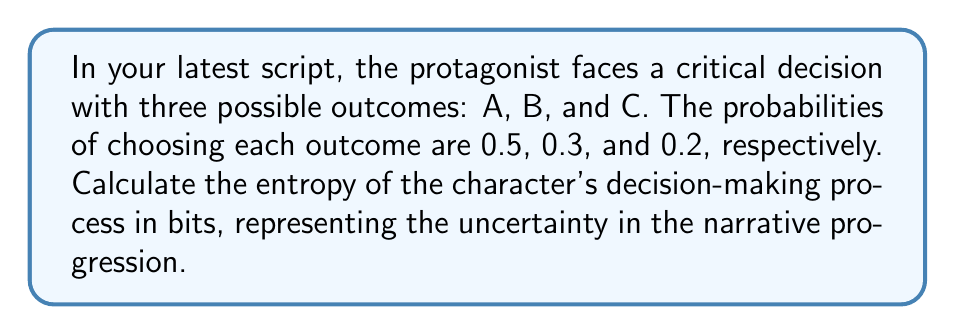Could you help me with this problem? To calculate the entropy of the character's decision-making process, we'll use the Shannon entropy formula:

$$ H = -\sum_{i=1}^{n} p_i \log_2(p_i) $$

Where:
- $H$ is the entropy in bits
- $p_i$ is the probability of each outcome
- $n$ is the number of possible outcomes

Step 1: Identify the probabilities
$p_A = 0.5$
$p_B = 0.3$
$p_C = 0.2$

Step 2: Calculate each term in the summation
For outcome A: $-0.5 \log_2(0.5) = 0.5$
For outcome B: $-0.3 \log_2(0.3) \approx 0.5211$
For outcome C: $-0.2 \log_2(0.2) \approx 0.4644$

Step 3: Sum all terms
$H = 0.5 + 0.5211 + 0.4644 = 1.4855$

Therefore, the entropy of the character's decision-making process is approximately 1.4855 bits.
Answer: 1.4855 bits 